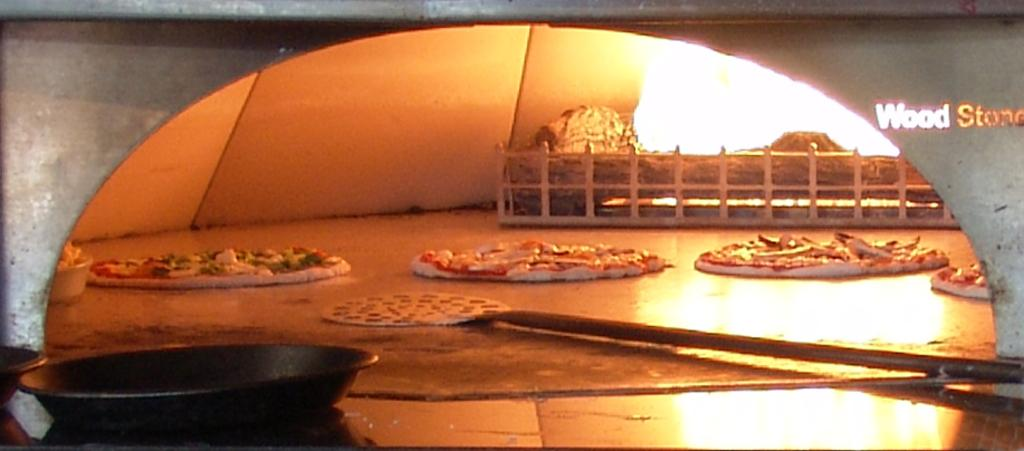<image>
Share a concise interpretation of the image provided. a pizza oven with the words 'Wood Stone' on the wall 